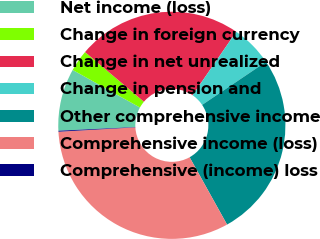Convert chart. <chart><loc_0><loc_0><loc_500><loc_500><pie_chart><fcel>Net income (loss)<fcel>Change in foreign currency<fcel>Change in net unrealized<fcel>Change in pension and<fcel>Other comprehensive income<fcel>Comprehensive income (loss)<fcel>Comprehensive (income) loss<nl><fcel>8.87%<fcel>3.05%<fcel>23.44%<fcel>5.96%<fcel>26.36%<fcel>32.18%<fcel>0.13%<nl></chart> 